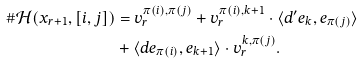Convert formula to latex. <formula><loc_0><loc_0><loc_500><loc_500>\# \mathcal { H } ( x _ { r + 1 } , [ i , j ] ) & = v _ { r } ^ { \pi ( i ) , \pi ( j ) } + v _ { r } ^ { \pi ( i ) , k + 1 } \cdot \langle d ^ { \prime } e _ { k } , e _ { \pi ( j ) } \rangle \\ & + \langle d e _ { \pi ( i ) } , e _ { k + 1 } \rangle \cdot v _ { r } ^ { k , \pi ( j ) } .</formula> 